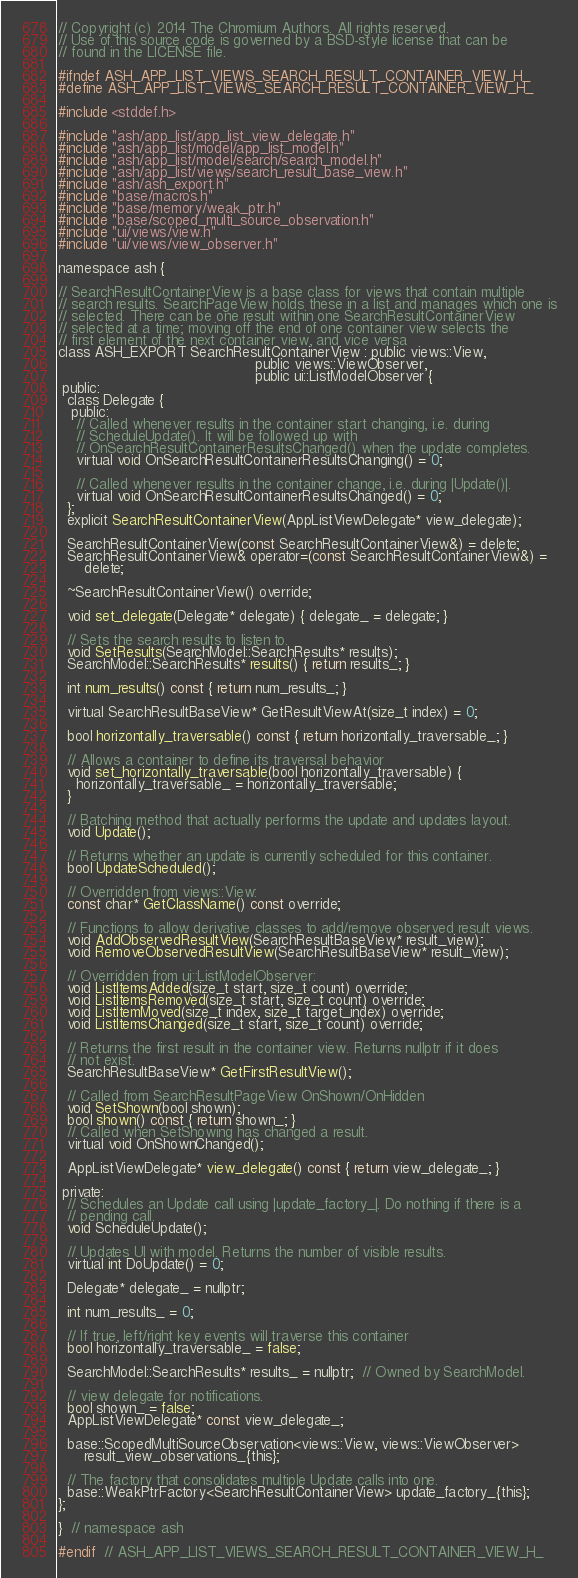<code> <loc_0><loc_0><loc_500><loc_500><_C_>// Copyright (c) 2014 The Chromium Authors. All rights reserved.
// Use of this source code is governed by a BSD-style license that can be
// found in the LICENSE file.

#ifndef ASH_APP_LIST_VIEWS_SEARCH_RESULT_CONTAINER_VIEW_H_
#define ASH_APP_LIST_VIEWS_SEARCH_RESULT_CONTAINER_VIEW_H_

#include <stddef.h>

#include "ash/app_list/app_list_view_delegate.h"
#include "ash/app_list/model/app_list_model.h"
#include "ash/app_list/model/search/search_model.h"
#include "ash/app_list/views/search_result_base_view.h"
#include "ash/ash_export.h"
#include "base/macros.h"
#include "base/memory/weak_ptr.h"
#include "base/scoped_multi_source_observation.h"
#include "ui/views/view.h"
#include "ui/views/view_observer.h"

namespace ash {

// SearchResultContainerView is a base class for views that contain multiple
// search results. SearchPageView holds these in a list and manages which one is
// selected. There can be one result within one SearchResultContainerView
// selected at a time; moving off the end of one container view selects the
// first element of the next container view, and vice versa
class ASH_EXPORT SearchResultContainerView : public views::View,
                                             public views::ViewObserver,
                                             public ui::ListModelObserver {
 public:
  class Delegate {
   public:
    // Called whenever results in the container start changing, i.e. during
    // ScheduleUpdate(). It will be followed up with
    // OnSearchResultContainerResultsChanged() when the update completes.
    virtual void OnSearchResultContainerResultsChanging() = 0;

    // Called whenever results in the container change, i.e. during |Update()|.
    virtual void OnSearchResultContainerResultsChanged() = 0;
  };
  explicit SearchResultContainerView(AppListViewDelegate* view_delegate);

  SearchResultContainerView(const SearchResultContainerView&) = delete;
  SearchResultContainerView& operator=(const SearchResultContainerView&) =
      delete;

  ~SearchResultContainerView() override;

  void set_delegate(Delegate* delegate) { delegate_ = delegate; }

  // Sets the search results to listen to.
  void SetResults(SearchModel::SearchResults* results);
  SearchModel::SearchResults* results() { return results_; }

  int num_results() const { return num_results_; }

  virtual SearchResultBaseView* GetResultViewAt(size_t index) = 0;

  bool horizontally_traversable() const { return horizontally_traversable_; }

  // Allows a container to define its traversal behavior
  void set_horizontally_traversable(bool horizontally_traversable) {
    horizontally_traversable_ = horizontally_traversable;
  }

  // Batching method that actually performs the update and updates layout.
  void Update();

  // Returns whether an update is currently scheduled for this container.
  bool UpdateScheduled();

  // Overridden from views::View:
  const char* GetClassName() const override;

  // Functions to allow derivative classes to add/remove observed result views.
  void AddObservedResultView(SearchResultBaseView* result_view);
  void RemoveObservedResultView(SearchResultBaseView* result_view);

  // Overridden from ui::ListModelObserver:
  void ListItemsAdded(size_t start, size_t count) override;
  void ListItemsRemoved(size_t start, size_t count) override;
  void ListItemMoved(size_t index, size_t target_index) override;
  void ListItemsChanged(size_t start, size_t count) override;

  // Returns the first result in the container view. Returns nullptr if it does
  // not exist.
  SearchResultBaseView* GetFirstResultView();

  // Called from SearchResultPageView OnShown/OnHidden
  void SetShown(bool shown);
  bool shown() const { return shown_; }
  // Called when SetShowing has changed a result.
  virtual void OnShownChanged();

  AppListViewDelegate* view_delegate() const { return view_delegate_; }

 private:
  // Schedules an Update call using |update_factory_|. Do nothing if there is a
  // pending call.
  void ScheduleUpdate();

  // Updates UI with model. Returns the number of visible results.
  virtual int DoUpdate() = 0;

  Delegate* delegate_ = nullptr;

  int num_results_ = 0;

  // If true, left/right key events will traverse this container
  bool horizontally_traversable_ = false;

  SearchModel::SearchResults* results_ = nullptr;  // Owned by SearchModel.

  // view delegate for notifications.
  bool shown_ = false;
  AppListViewDelegate* const view_delegate_;

  base::ScopedMultiSourceObservation<views::View, views::ViewObserver>
      result_view_observations_{this};

  // The factory that consolidates multiple Update calls into one.
  base::WeakPtrFactory<SearchResultContainerView> update_factory_{this};
};

}  // namespace ash

#endif  // ASH_APP_LIST_VIEWS_SEARCH_RESULT_CONTAINER_VIEW_H_
</code> 